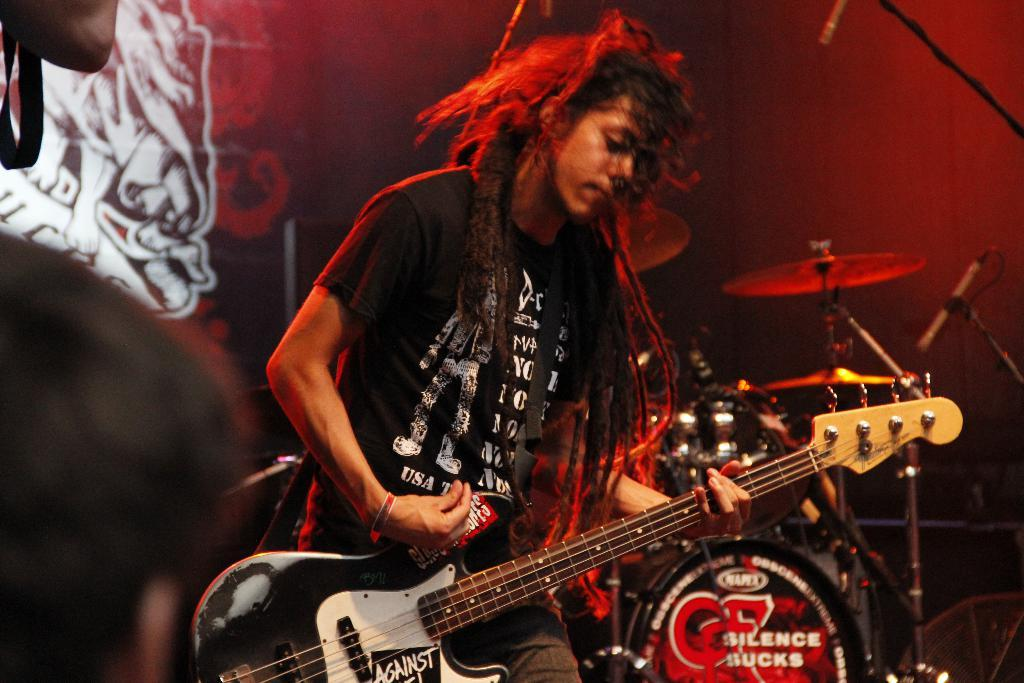What is the man in the image doing? The man is playing a guitar in the image. What other musical instrument can be seen in the image? There is a musical instrument in the background, but it is not specified which one. What is visible in the background of the image? There is a wall in the background of the image. Where is the kettle located in the image? There is no kettle present in the image. Can you describe the hill in the background of the image? There is no hill present in the image; it only features a wall in the background. 